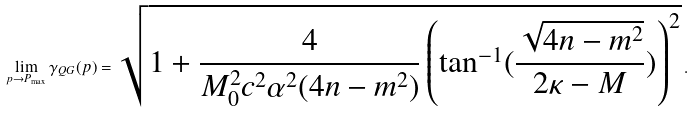Convert formula to latex. <formula><loc_0><loc_0><loc_500><loc_500>\lim _ { p \rightarrow P _ { \max } } \gamma _ { Q G } ( p ) = { \sqrt { 1 + \frac { 4 } { M _ { 0 } ^ { 2 } c ^ { 2 } \alpha ^ { 2 } ( 4 n - m ^ { 2 } ) } \left ( \tan ^ { - 1 } ( \frac { \sqrt { 4 n - m ^ { 2 } } } { 2 \kappa - M } ) \right ) ^ { 2 } } } \, .</formula> 